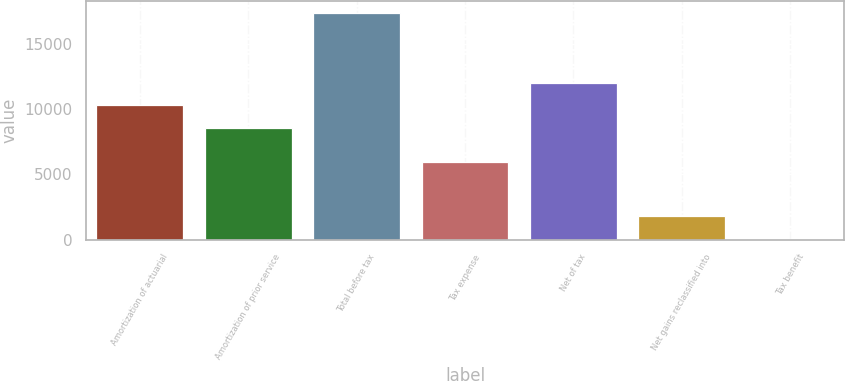<chart> <loc_0><loc_0><loc_500><loc_500><bar_chart><fcel>Amortization of actuarial<fcel>Amortization of prior service<fcel>Total before tax<fcel>Tax expense<fcel>Net of tax<fcel>Net gains reclassified into<fcel>Tax benefit<nl><fcel>10288.1<fcel>8556<fcel>17378<fcel>5969<fcel>12020.2<fcel>1789.1<fcel>57<nl></chart> 